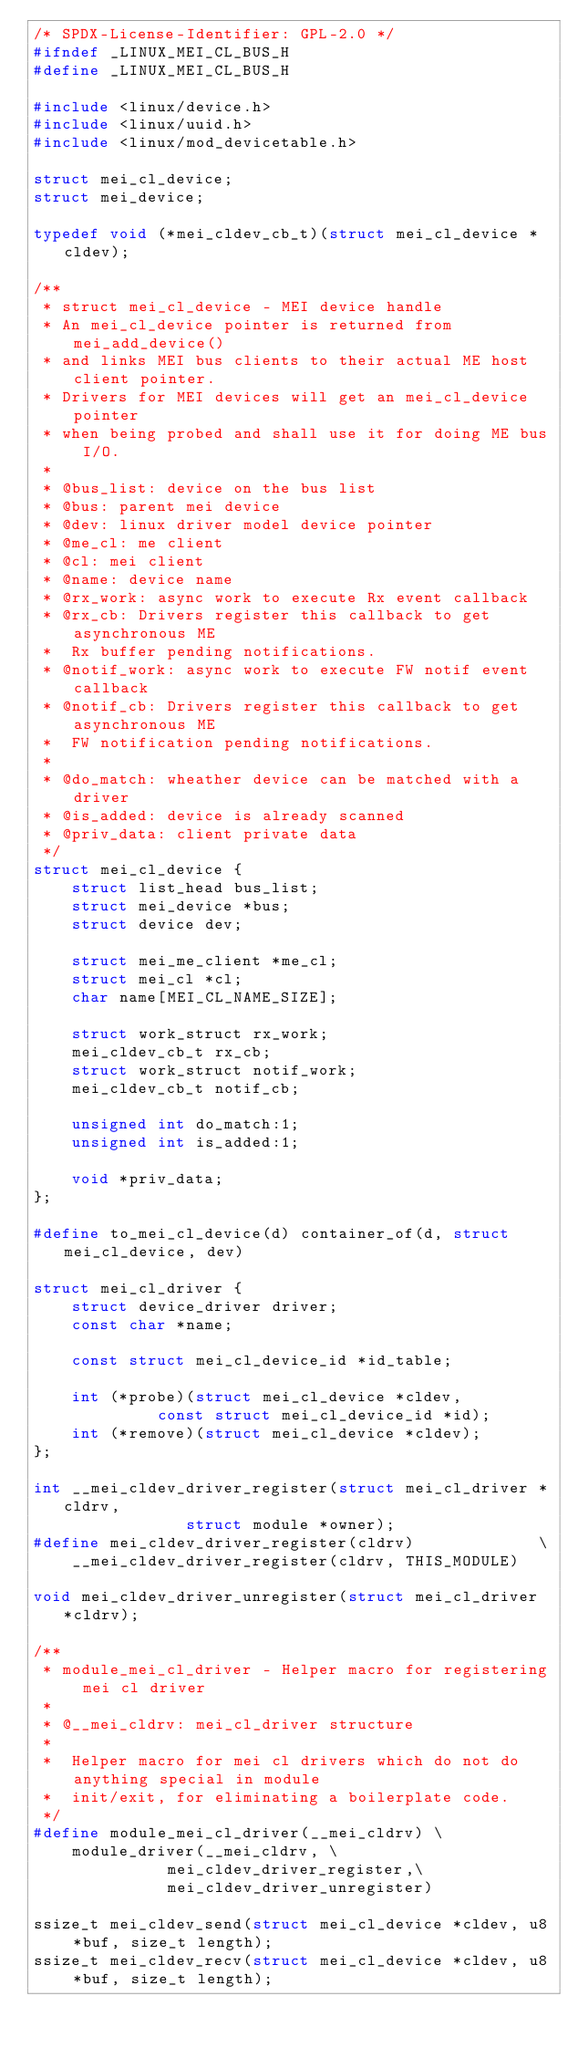<code> <loc_0><loc_0><loc_500><loc_500><_C_>/* SPDX-License-Identifier: GPL-2.0 */
#ifndef _LINUX_MEI_CL_BUS_H
#define _LINUX_MEI_CL_BUS_H

#include <linux/device.h>
#include <linux/uuid.h>
#include <linux/mod_devicetable.h>

struct mei_cl_device;
struct mei_device;

typedef void (*mei_cldev_cb_t)(struct mei_cl_device *cldev);

/**
 * struct mei_cl_device - MEI device handle
 * An mei_cl_device pointer is returned from mei_add_device()
 * and links MEI bus clients to their actual ME host client pointer.
 * Drivers for MEI devices will get an mei_cl_device pointer
 * when being probed and shall use it for doing ME bus I/O.
 *
 * @bus_list: device on the bus list
 * @bus: parent mei device
 * @dev: linux driver model device pointer
 * @me_cl: me client
 * @cl: mei client
 * @name: device name
 * @rx_work: async work to execute Rx event callback
 * @rx_cb: Drivers register this callback to get asynchronous ME
 *	Rx buffer pending notifications.
 * @notif_work: async work to execute FW notif event callback
 * @notif_cb: Drivers register this callback to get asynchronous ME
 *	FW notification pending notifications.
 *
 * @do_match: wheather device can be matched with a driver
 * @is_added: device is already scanned
 * @priv_data: client private data
 */
struct mei_cl_device {
	struct list_head bus_list;
	struct mei_device *bus;
	struct device dev;

	struct mei_me_client *me_cl;
	struct mei_cl *cl;
	char name[MEI_CL_NAME_SIZE];

	struct work_struct rx_work;
	mei_cldev_cb_t rx_cb;
	struct work_struct notif_work;
	mei_cldev_cb_t notif_cb;

	unsigned int do_match:1;
	unsigned int is_added:1;

	void *priv_data;
};

#define to_mei_cl_device(d) container_of(d, struct mei_cl_device, dev)

struct mei_cl_driver {
	struct device_driver driver;
	const char *name;

	const struct mei_cl_device_id *id_table;

	int (*probe)(struct mei_cl_device *cldev,
		     const struct mei_cl_device_id *id);
	int (*remove)(struct mei_cl_device *cldev);
};

int __mei_cldev_driver_register(struct mei_cl_driver *cldrv,
				struct module *owner);
#define mei_cldev_driver_register(cldrv)             \
	__mei_cldev_driver_register(cldrv, THIS_MODULE)

void mei_cldev_driver_unregister(struct mei_cl_driver *cldrv);

/**
 * module_mei_cl_driver - Helper macro for registering mei cl driver
 *
 * @__mei_cldrv: mei_cl_driver structure
 *
 *  Helper macro for mei cl drivers which do not do anything special in module
 *  init/exit, for eliminating a boilerplate code.
 */
#define module_mei_cl_driver(__mei_cldrv) \
	module_driver(__mei_cldrv, \
		      mei_cldev_driver_register,\
		      mei_cldev_driver_unregister)

ssize_t mei_cldev_send(struct mei_cl_device *cldev, u8 *buf, size_t length);
ssize_t mei_cldev_recv(struct mei_cl_device *cldev, u8 *buf, size_t length);</code> 